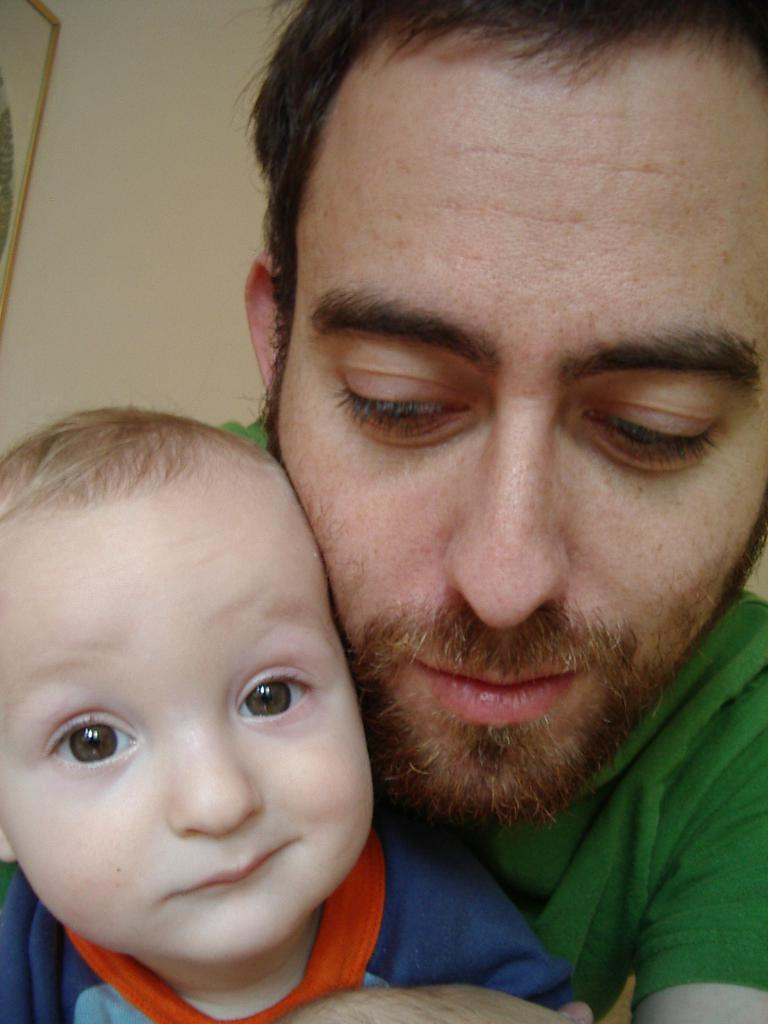Who is present in the image? There is a man and a child in the image. Where are the man and child located in the image? The man and child are in the front of the image. What can be seen in the background of the image? There is a wall in the background of the image. What type of zephyr can be seen blowing the child's hair in the image? There is no zephyr present in the image, and the child's hair is not being blown by any wind. What is the child using to hold the pin in place in the image? There is no pin present in the image, so it cannot be held in place. 